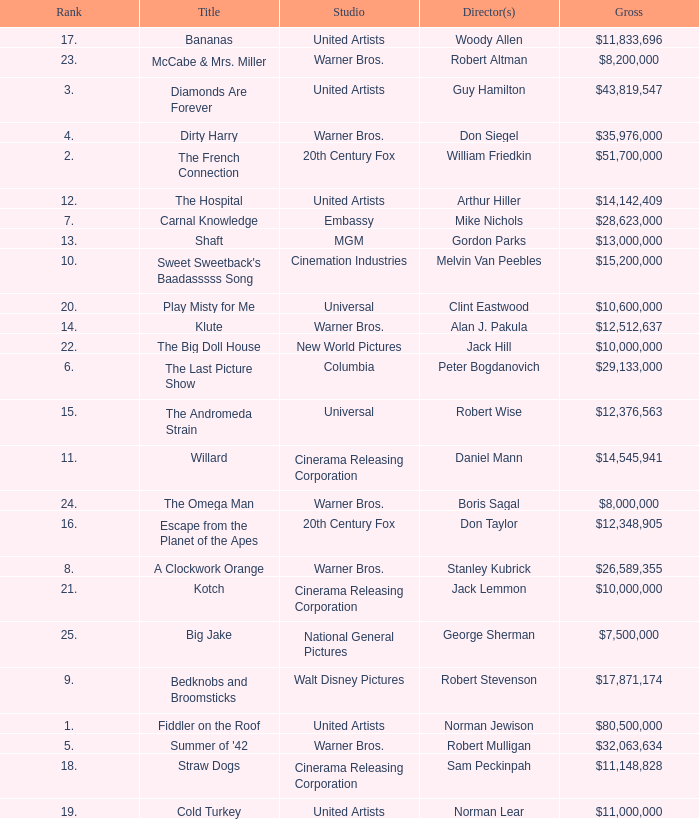Could you parse the entire table? {'header': ['Rank', 'Title', 'Studio', 'Director(s)', 'Gross'], 'rows': [['17.', 'Bananas', 'United Artists', 'Woody Allen', '$11,833,696'], ['23.', 'McCabe & Mrs. Miller', 'Warner Bros.', 'Robert Altman', '$8,200,000'], ['3.', 'Diamonds Are Forever', 'United Artists', 'Guy Hamilton', '$43,819,547'], ['4.', 'Dirty Harry', 'Warner Bros.', 'Don Siegel', '$35,976,000'], ['2.', 'The French Connection', '20th Century Fox', 'William Friedkin', '$51,700,000'], ['12.', 'The Hospital', 'United Artists', 'Arthur Hiller', '$14,142,409'], ['7.', 'Carnal Knowledge', 'Embassy', 'Mike Nichols', '$28,623,000'], ['13.', 'Shaft', 'MGM', 'Gordon Parks', '$13,000,000'], ['10.', "Sweet Sweetback's Baadasssss Song", 'Cinemation Industries', 'Melvin Van Peebles', '$15,200,000'], ['20.', 'Play Misty for Me', 'Universal', 'Clint Eastwood', '$10,600,000'], ['14.', 'Klute', 'Warner Bros.', 'Alan J. Pakula', '$12,512,637'], ['22.', 'The Big Doll House', 'New World Pictures', 'Jack Hill', '$10,000,000'], ['6.', 'The Last Picture Show', 'Columbia', 'Peter Bogdanovich', '$29,133,000'], ['15.', 'The Andromeda Strain', 'Universal', 'Robert Wise', '$12,376,563'], ['11.', 'Willard', 'Cinerama Releasing Corporation', 'Daniel Mann', '$14,545,941'], ['24.', 'The Omega Man', 'Warner Bros.', 'Boris Sagal', '$8,000,000'], ['16.', 'Escape from the Planet of the Apes', '20th Century Fox', 'Don Taylor', '$12,348,905'], ['8.', 'A Clockwork Orange', 'Warner Bros.', 'Stanley Kubrick', '$26,589,355'], ['21.', 'Kotch', 'Cinerama Releasing Corporation', 'Jack Lemmon', '$10,000,000'], ['25.', 'Big Jake', 'National General Pictures', 'George Sherman', '$7,500,000'], ['9.', 'Bedknobs and Broomsticks', 'Walt Disney Pictures', 'Robert Stevenson', '$17,871,174'], ['1.', 'Fiddler on the Roof', 'United Artists', 'Norman Jewison', '$80,500,000'], ['5.', "Summer of '42", 'Warner Bros.', 'Robert Mulligan', '$32,063,634'], ['18.', 'Straw Dogs', 'Cinerama Releasing Corporation', 'Sam Peckinpah', '$11,148,828'], ['19.', 'Cold Turkey', 'United Artists', 'Norman Lear', '$11,000,000']]} What is the rank of The Big Doll House? 22.0. 